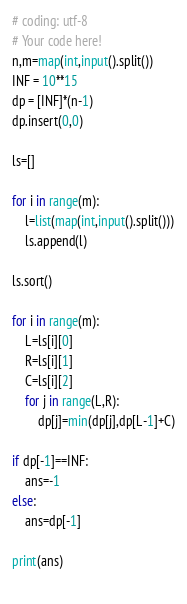Convert code to text. <code><loc_0><loc_0><loc_500><loc_500><_Python_># coding: utf-8
# Your code here!
n,m=map(int,input().split())
INF = 10**15
dp = [INF]*(n-1)
dp.insert(0,0)

ls=[]

for i in range(m):
    l=list(map(int,input().split()))
    ls.append(l)

ls.sort()

for i in range(m):
    L=ls[i][0]
    R=ls[i][1]
    C=ls[i][2]
    for j in range(L,R):
        dp[j]=min(dp[j],dp[L-1]+C)
        
if dp[-1]==INF:
    ans=-1
else:
    ans=dp[-1]

print(ans)
    
</code> 